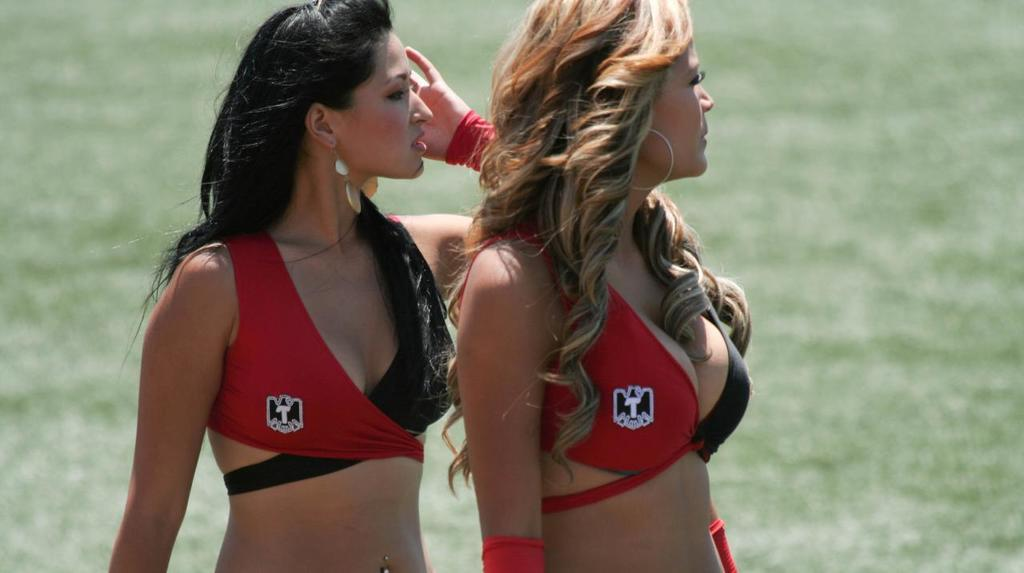<image>
Present a compact description of the photo's key features. Two women wearing an emblem with a capital T on their uniform. 